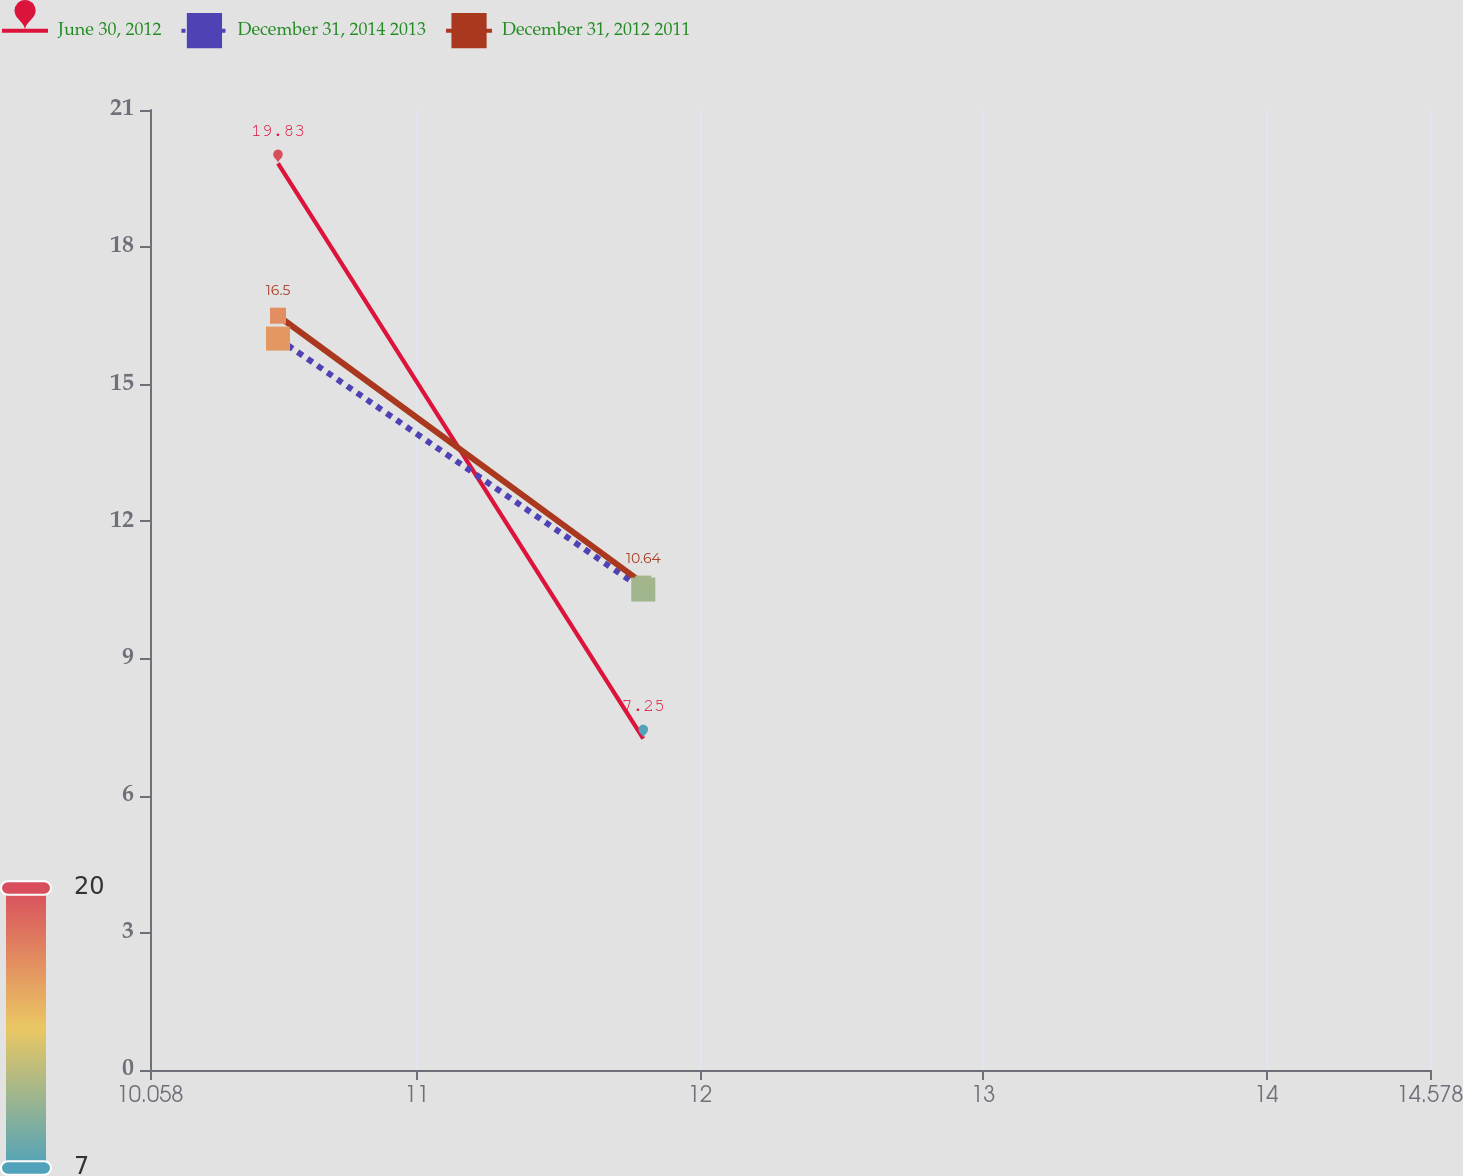Convert chart. <chart><loc_0><loc_0><loc_500><loc_500><line_chart><ecel><fcel>June 30, 2012<fcel>December 31, 2014 2013<fcel>December 31, 2012 2011<nl><fcel>10.51<fcel>19.83<fcel>16<fcel>16.5<nl><fcel>11.8<fcel>7.25<fcel>10.51<fcel>10.64<nl><fcel>15.03<fcel>12.79<fcel>11.06<fcel>9.35<nl></chart> 